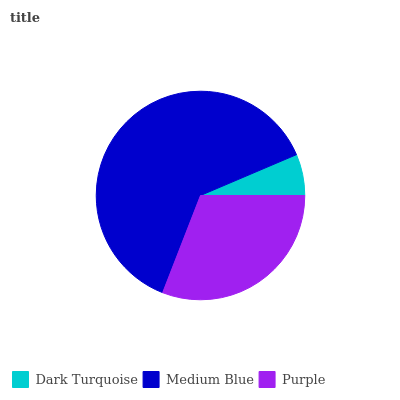Is Dark Turquoise the minimum?
Answer yes or no. Yes. Is Medium Blue the maximum?
Answer yes or no. Yes. Is Purple the minimum?
Answer yes or no. No. Is Purple the maximum?
Answer yes or no. No. Is Medium Blue greater than Purple?
Answer yes or no. Yes. Is Purple less than Medium Blue?
Answer yes or no. Yes. Is Purple greater than Medium Blue?
Answer yes or no. No. Is Medium Blue less than Purple?
Answer yes or no. No. Is Purple the high median?
Answer yes or no. Yes. Is Purple the low median?
Answer yes or no. Yes. Is Medium Blue the high median?
Answer yes or no. No. Is Medium Blue the low median?
Answer yes or no. No. 